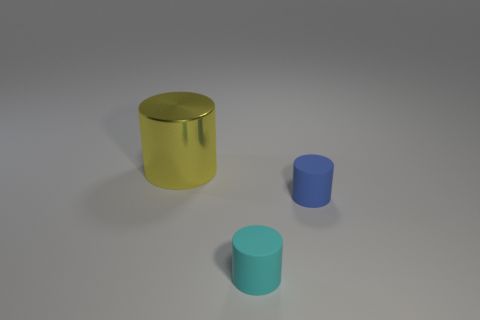What number of cylinders are right of the big yellow object behind the tiny cyan rubber cylinder?
Your answer should be very brief. 2. What number of other things are there of the same material as the yellow cylinder
Offer a terse response. 0. Is the small object that is left of the blue rubber object made of the same material as the cylinder that is behind the tiny blue rubber object?
Ensure brevity in your answer.  No. Do the large cylinder and the object right of the cyan matte cylinder have the same material?
Ensure brevity in your answer.  No. The small matte cylinder in front of the blue rubber object that is on the right side of the tiny rubber cylinder to the left of the small blue matte cylinder is what color?
Ensure brevity in your answer.  Cyan. Is there anything else that has the same size as the metal cylinder?
Your answer should be compact. No. There is a rubber cylinder on the right side of the tiny cyan cylinder; does it have the same size as the object behind the blue thing?
Keep it short and to the point. No. What size is the matte object behind the cyan object?
Give a very brief answer. Small. What color is the other matte object that is the same size as the blue thing?
Provide a succinct answer. Cyan. Do the blue matte cylinder and the yellow cylinder have the same size?
Ensure brevity in your answer.  No. 